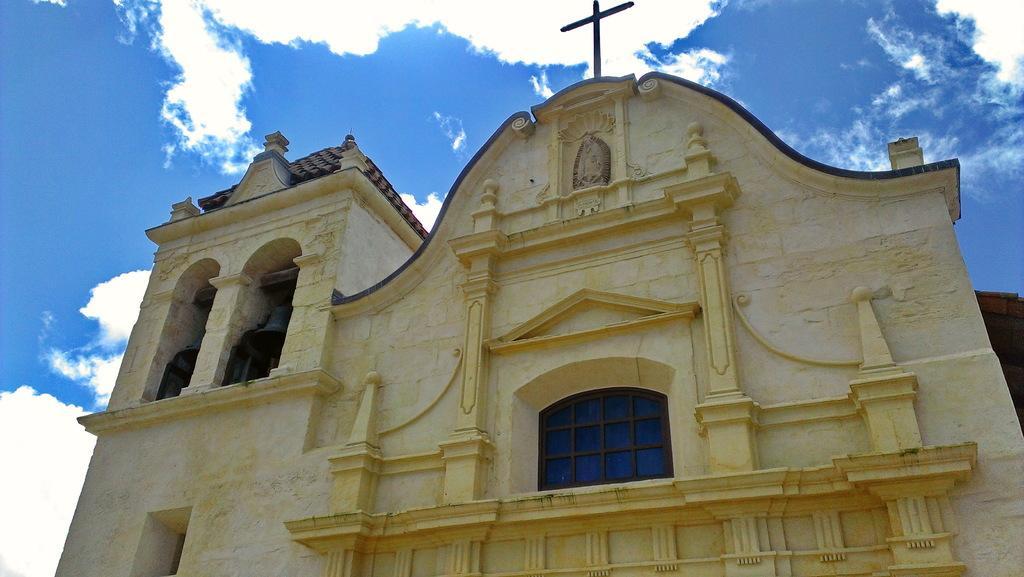Could you give a brief overview of what you see in this image? In this picture we can see a close view of the yellow Church building. In the front there is a glass window and cross mark on the top. Above we can see the sky and clouds. 